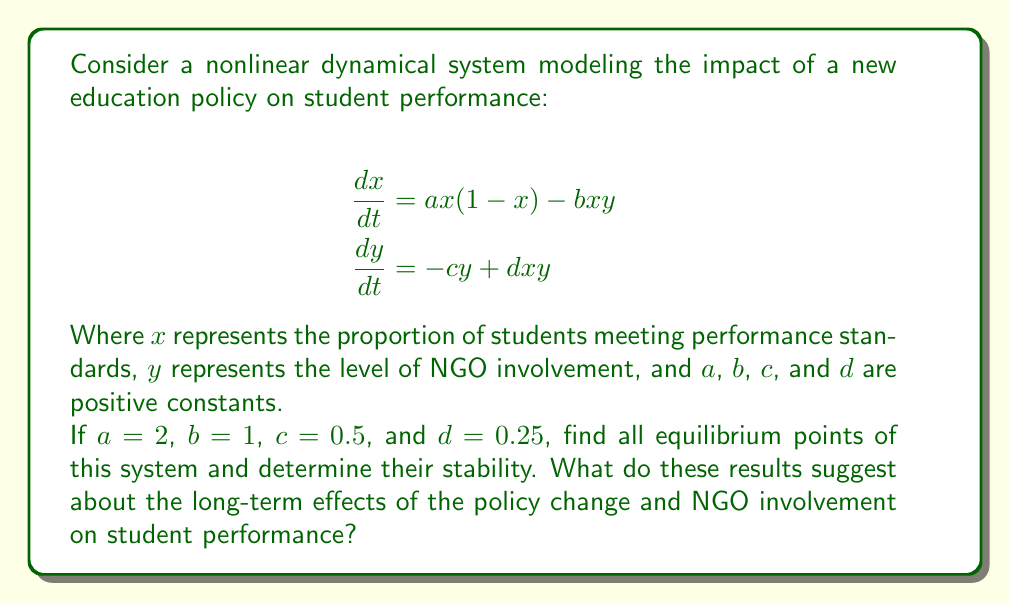Provide a solution to this math problem. Step 1: Find the equilibrium points by setting both equations to zero:

$$ax(1-x) - bxy = 0$$
$$-cy + dxy = 0$$

Step 2: Substitute the given values:

$$2x(1-x) - xy = 0$$
$$-0.5y + 0.25xy = 0$$

Step 3: From the second equation, we get:
$$y(0.25x - 0.5) = 0$$
This implies either $y = 0$ or $x = 2$.

Step 4: If $y = 0$, substitute into the first equation:
$$2x(1-x) = 0$$
This gives $x = 0$ or $x = 1$.

Step 5: If $x = 2$, substitute into the first equation:
$$2(2)(1-2) - 2y = 0$$
$$-4 - 2y = 0$$
$$y = -2$$

However, since $y$ represents a proportion, negative values are not meaningful in this context.

Step 6: Therefore, we have two equilibrium points: $(0,0)$ and $(1,0)$.

Step 7: To determine stability, we need to find the Jacobian matrix:

$$J = \begin{bmatrix}
a(1-2x) - by & -bx \\
dy & -c + dx
\end{bmatrix}$$

Step 8: Evaluate the Jacobian at $(0,0)$:

$$J_{(0,0)} = \begin{bmatrix}
2 & 0 \\
0 & -0.5
\end{bmatrix}$$

The eigenvalues are 2 and -0.5, indicating an unstable saddle point.

Step 9: Evaluate the Jacobian at $(1,0)$:

$$J_{(1,0)} = \begin{bmatrix}
-2 & -1 \\
0 & -0.25
\end{bmatrix}$$

The eigenvalues are -2 and -0.25, indicating a stable node.

Interpretation: The stable equilibrium point $(1,0)$ suggests that in the long term, the policy change will lead to all students meeting performance standards without NGO involvement. The unstable equilibrium $(0,0)$ represents a scenario where no students meet standards and there's no NGO involvement, but this state is unlikely to persist.
Answer: Two equilibrium points: $(0,0)$ (unstable saddle) and $(1,0)$ (stable node). Long-term: all students meet standards, no NGO involvement. 